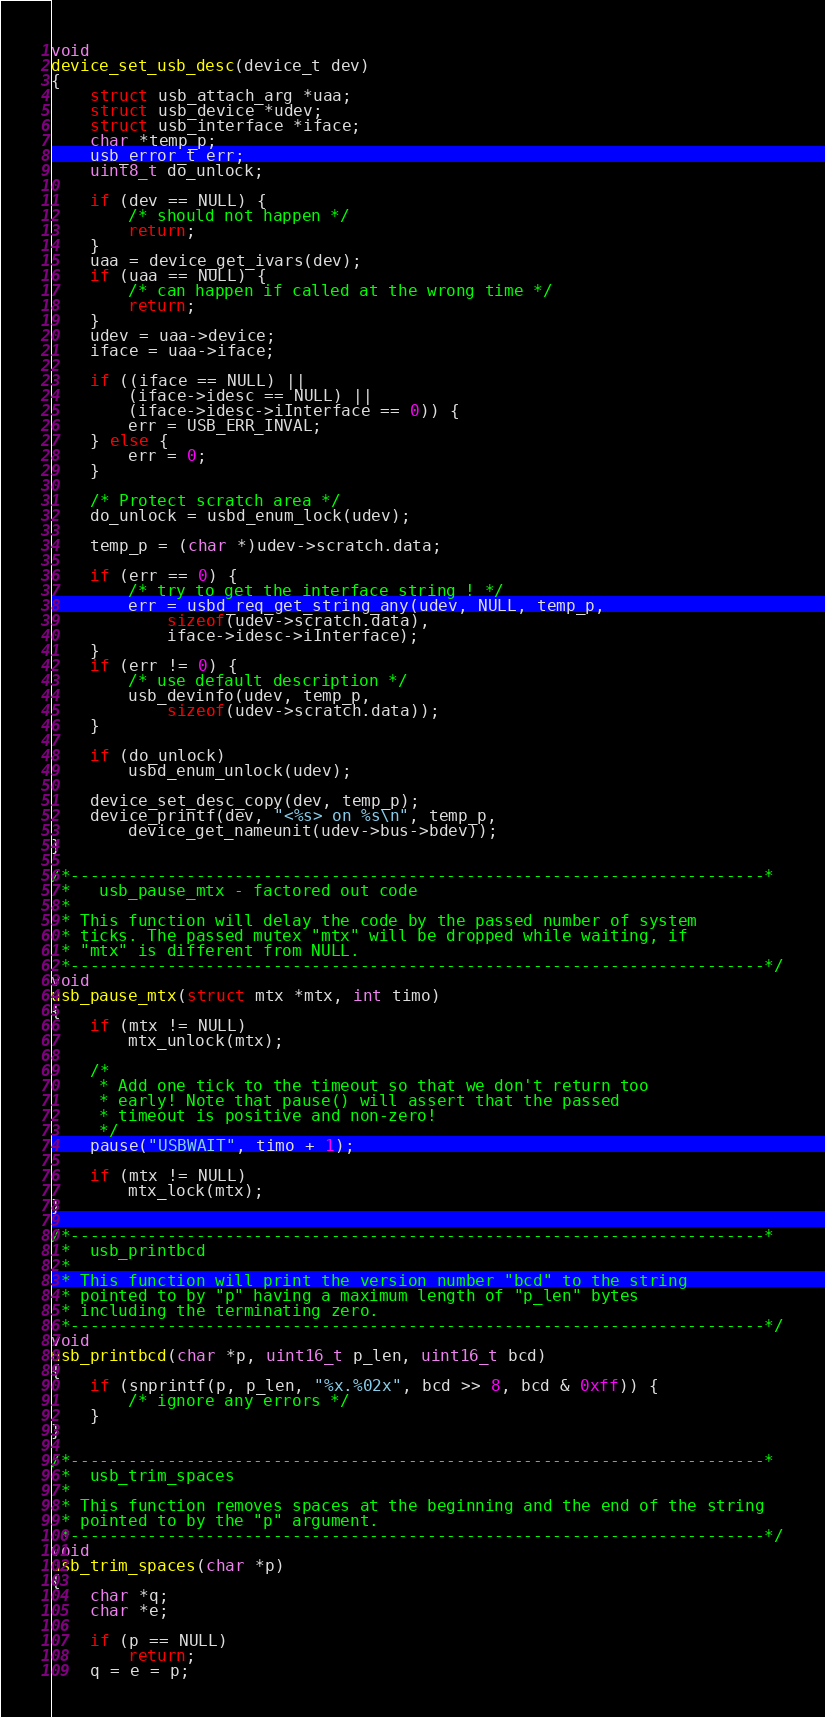Convert code to text. <code><loc_0><loc_0><loc_500><loc_500><_C_>void
device_set_usb_desc(device_t dev)
{
	struct usb_attach_arg *uaa;
	struct usb_device *udev;
	struct usb_interface *iface;
	char *temp_p;
	usb_error_t err;
	uint8_t do_unlock;

	if (dev == NULL) {
		/* should not happen */
		return;
	}
	uaa = device_get_ivars(dev);
	if (uaa == NULL) {
		/* can happen if called at the wrong time */
		return;
	}
	udev = uaa->device;
	iface = uaa->iface;

	if ((iface == NULL) ||
	    (iface->idesc == NULL) ||
	    (iface->idesc->iInterface == 0)) {
		err = USB_ERR_INVAL;
	} else {
		err = 0;
	}

	/* Protect scratch area */
	do_unlock = usbd_enum_lock(udev);

	temp_p = (char *)udev->scratch.data;

	if (err == 0) {
		/* try to get the interface string ! */
		err = usbd_req_get_string_any(udev, NULL, temp_p,
		    sizeof(udev->scratch.data),
		    iface->idesc->iInterface);
	}
	if (err != 0) {
		/* use default description */
		usb_devinfo(udev, temp_p,
		    sizeof(udev->scratch.data));
	}

	if (do_unlock)
		usbd_enum_unlock(udev);

	device_set_desc_copy(dev, temp_p);
	device_printf(dev, "<%s> on %s\n", temp_p,
	    device_get_nameunit(udev->bus->bdev));
}

/*------------------------------------------------------------------------*
 *	 usb_pause_mtx - factored out code
 *
 * This function will delay the code by the passed number of system
 * ticks. The passed mutex "mtx" will be dropped while waiting, if
 * "mtx" is different from NULL.
 *------------------------------------------------------------------------*/
void
usb_pause_mtx(struct mtx *mtx, int timo)
{
	if (mtx != NULL)
		mtx_unlock(mtx);

	/*
	 * Add one tick to the timeout so that we don't return too
	 * early! Note that pause() will assert that the passed
	 * timeout is positive and non-zero!
	 */
	pause("USBWAIT", timo + 1);

	if (mtx != NULL)
		mtx_lock(mtx);
}

/*------------------------------------------------------------------------*
 *	usb_printbcd
 *
 * This function will print the version number "bcd" to the string
 * pointed to by "p" having a maximum length of "p_len" bytes
 * including the terminating zero.
 *------------------------------------------------------------------------*/
void
usb_printbcd(char *p, uint16_t p_len, uint16_t bcd)
{
	if (snprintf(p, p_len, "%x.%02x", bcd >> 8, bcd & 0xff)) {
		/* ignore any errors */
	}
}

/*------------------------------------------------------------------------*
 *	usb_trim_spaces
 *
 * This function removes spaces at the beginning and the end of the string
 * pointed to by the "p" argument.
 *------------------------------------------------------------------------*/
void
usb_trim_spaces(char *p)
{
	char *q;
	char *e;

	if (p == NULL)
		return;
	q = e = p;</code> 